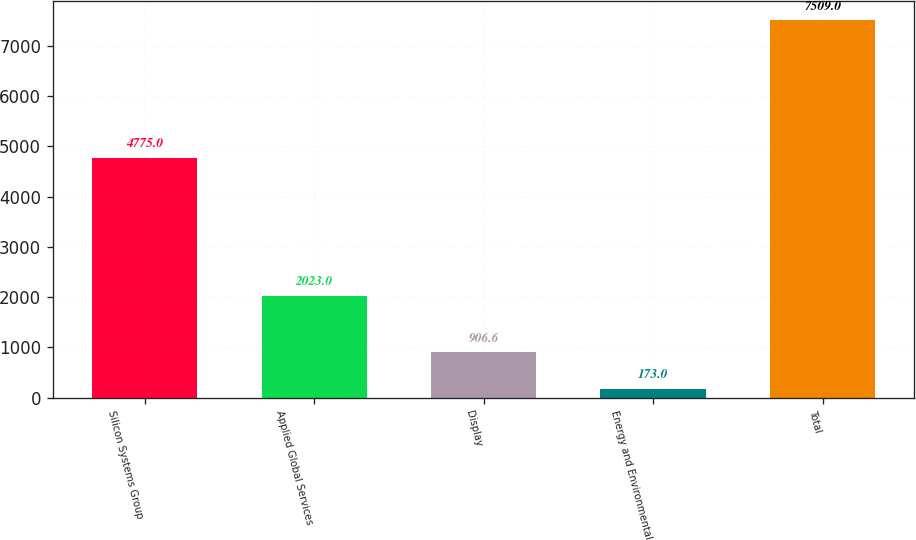Convert chart. <chart><loc_0><loc_0><loc_500><loc_500><bar_chart><fcel>Silicon Systems Group<fcel>Applied Global Services<fcel>Display<fcel>Energy and Environmental<fcel>Total<nl><fcel>4775<fcel>2023<fcel>906.6<fcel>173<fcel>7509<nl></chart> 